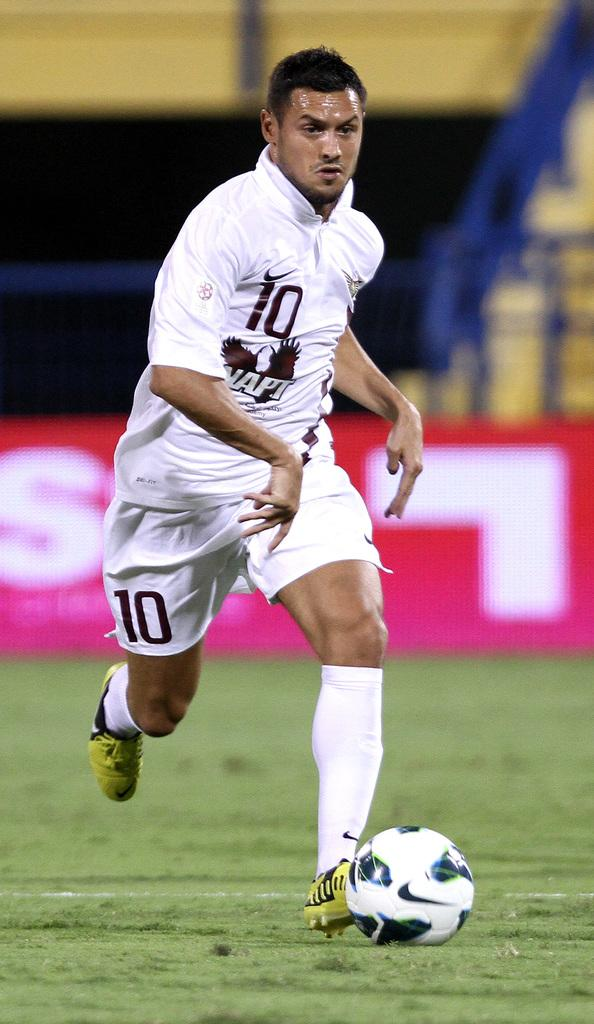<image>
Create a compact narrative representing the image presented. Football player number 10 kicks the ball on the field.. 